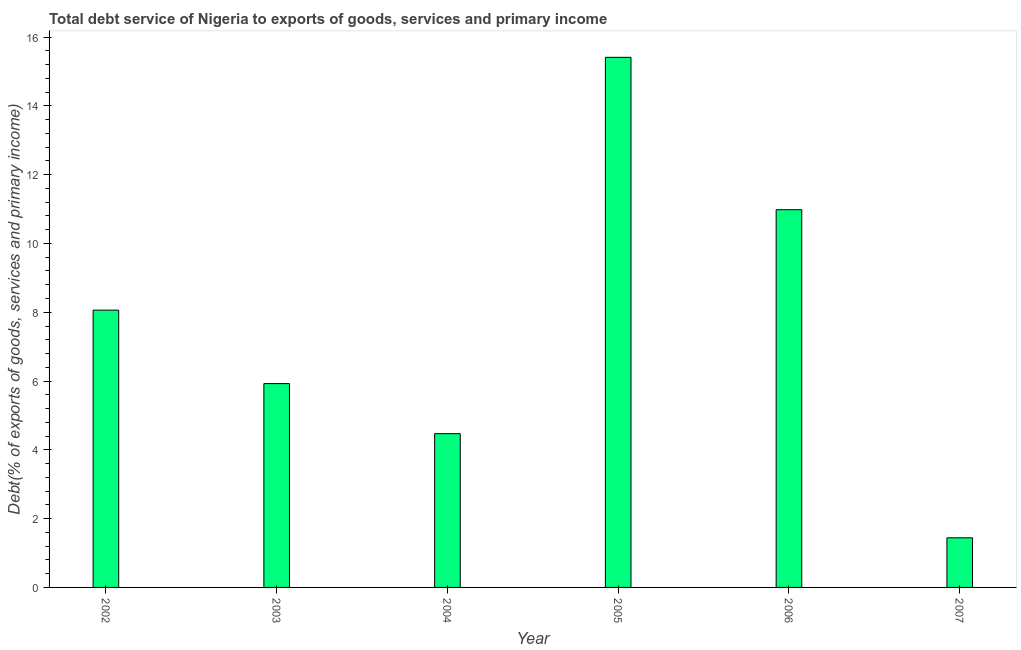Does the graph contain any zero values?
Offer a terse response. No. Does the graph contain grids?
Ensure brevity in your answer.  No. What is the title of the graph?
Give a very brief answer. Total debt service of Nigeria to exports of goods, services and primary income. What is the label or title of the Y-axis?
Your answer should be compact. Debt(% of exports of goods, services and primary income). What is the total debt service in 2002?
Ensure brevity in your answer.  8.06. Across all years, what is the maximum total debt service?
Provide a succinct answer. 15.41. Across all years, what is the minimum total debt service?
Offer a very short reply. 1.44. In which year was the total debt service maximum?
Offer a terse response. 2005. What is the sum of the total debt service?
Offer a very short reply. 46.29. What is the difference between the total debt service in 2005 and 2006?
Make the answer very short. 4.43. What is the average total debt service per year?
Ensure brevity in your answer.  7.71. What is the median total debt service?
Your answer should be compact. 6.99. In how many years, is the total debt service greater than 13.6 %?
Offer a very short reply. 1. Do a majority of the years between 2002 and 2003 (inclusive) have total debt service greater than 10.8 %?
Ensure brevity in your answer.  No. What is the ratio of the total debt service in 2005 to that in 2007?
Your response must be concise. 10.68. Is the difference between the total debt service in 2004 and 2006 greater than the difference between any two years?
Provide a succinct answer. No. What is the difference between the highest and the second highest total debt service?
Keep it short and to the point. 4.43. What is the difference between the highest and the lowest total debt service?
Give a very brief answer. 13.97. In how many years, is the total debt service greater than the average total debt service taken over all years?
Give a very brief answer. 3. Are all the bars in the graph horizontal?
Offer a terse response. No. How many years are there in the graph?
Provide a short and direct response. 6. What is the difference between two consecutive major ticks on the Y-axis?
Provide a succinct answer. 2. Are the values on the major ticks of Y-axis written in scientific E-notation?
Provide a short and direct response. No. What is the Debt(% of exports of goods, services and primary income) in 2002?
Offer a terse response. 8.06. What is the Debt(% of exports of goods, services and primary income) in 2003?
Offer a terse response. 5.93. What is the Debt(% of exports of goods, services and primary income) of 2004?
Keep it short and to the point. 4.47. What is the Debt(% of exports of goods, services and primary income) in 2005?
Your answer should be compact. 15.41. What is the Debt(% of exports of goods, services and primary income) in 2006?
Your answer should be compact. 10.98. What is the Debt(% of exports of goods, services and primary income) in 2007?
Provide a succinct answer. 1.44. What is the difference between the Debt(% of exports of goods, services and primary income) in 2002 and 2003?
Provide a succinct answer. 2.14. What is the difference between the Debt(% of exports of goods, services and primary income) in 2002 and 2004?
Offer a very short reply. 3.59. What is the difference between the Debt(% of exports of goods, services and primary income) in 2002 and 2005?
Provide a short and direct response. -7.35. What is the difference between the Debt(% of exports of goods, services and primary income) in 2002 and 2006?
Your response must be concise. -2.92. What is the difference between the Debt(% of exports of goods, services and primary income) in 2002 and 2007?
Provide a succinct answer. 6.62. What is the difference between the Debt(% of exports of goods, services and primary income) in 2003 and 2004?
Make the answer very short. 1.46. What is the difference between the Debt(% of exports of goods, services and primary income) in 2003 and 2005?
Ensure brevity in your answer.  -9.49. What is the difference between the Debt(% of exports of goods, services and primary income) in 2003 and 2006?
Provide a short and direct response. -5.06. What is the difference between the Debt(% of exports of goods, services and primary income) in 2003 and 2007?
Your answer should be compact. 4.48. What is the difference between the Debt(% of exports of goods, services and primary income) in 2004 and 2005?
Your answer should be very brief. -10.94. What is the difference between the Debt(% of exports of goods, services and primary income) in 2004 and 2006?
Give a very brief answer. -6.51. What is the difference between the Debt(% of exports of goods, services and primary income) in 2004 and 2007?
Your response must be concise. 3.03. What is the difference between the Debt(% of exports of goods, services and primary income) in 2005 and 2006?
Your answer should be very brief. 4.43. What is the difference between the Debt(% of exports of goods, services and primary income) in 2005 and 2007?
Your response must be concise. 13.97. What is the difference between the Debt(% of exports of goods, services and primary income) in 2006 and 2007?
Give a very brief answer. 9.54. What is the ratio of the Debt(% of exports of goods, services and primary income) in 2002 to that in 2003?
Provide a short and direct response. 1.36. What is the ratio of the Debt(% of exports of goods, services and primary income) in 2002 to that in 2004?
Your answer should be compact. 1.8. What is the ratio of the Debt(% of exports of goods, services and primary income) in 2002 to that in 2005?
Provide a short and direct response. 0.52. What is the ratio of the Debt(% of exports of goods, services and primary income) in 2002 to that in 2006?
Give a very brief answer. 0.73. What is the ratio of the Debt(% of exports of goods, services and primary income) in 2002 to that in 2007?
Provide a short and direct response. 5.59. What is the ratio of the Debt(% of exports of goods, services and primary income) in 2003 to that in 2004?
Offer a very short reply. 1.33. What is the ratio of the Debt(% of exports of goods, services and primary income) in 2003 to that in 2005?
Ensure brevity in your answer.  0.39. What is the ratio of the Debt(% of exports of goods, services and primary income) in 2003 to that in 2006?
Offer a terse response. 0.54. What is the ratio of the Debt(% of exports of goods, services and primary income) in 2003 to that in 2007?
Provide a short and direct response. 4.11. What is the ratio of the Debt(% of exports of goods, services and primary income) in 2004 to that in 2005?
Your answer should be compact. 0.29. What is the ratio of the Debt(% of exports of goods, services and primary income) in 2004 to that in 2006?
Offer a terse response. 0.41. What is the ratio of the Debt(% of exports of goods, services and primary income) in 2004 to that in 2007?
Provide a succinct answer. 3.1. What is the ratio of the Debt(% of exports of goods, services and primary income) in 2005 to that in 2006?
Offer a very short reply. 1.4. What is the ratio of the Debt(% of exports of goods, services and primary income) in 2005 to that in 2007?
Your response must be concise. 10.68. What is the ratio of the Debt(% of exports of goods, services and primary income) in 2006 to that in 2007?
Ensure brevity in your answer.  7.61. 